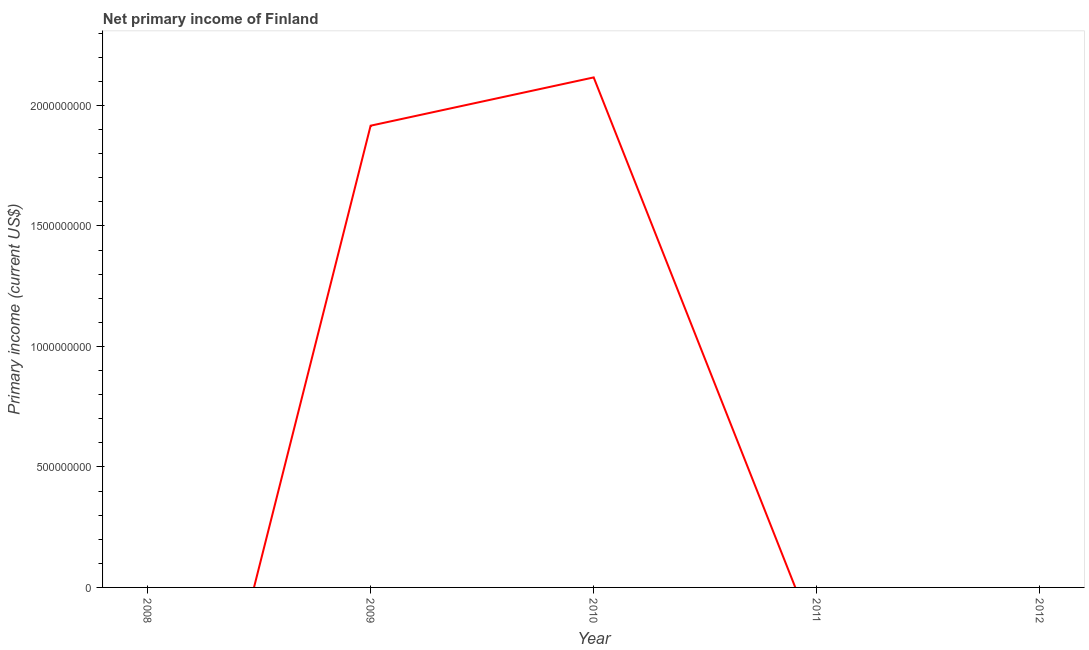What is the amount of primary income in 2009?
Your answer should be compact. 1.92e+09. Across all years, what is the maximum amount of primary income?
Offer a very short reply. 2.12e+09. In which year was the amount of primary income maximum?
Ensure brevity in your answer.  2010. What is the sum of the amount of primary income?
Your answer should be very brief. 4.03e+09. What is the difference between the amount of primary income in 2009 and 2010?
Give a very brief answer. -2.00e+08. What is the average amount of primary income per year?
Give a very brief answer. 8.06e+08. In how many years, is the amount of primary income greater than 300000000 US$?
Offer a very short reply. 2. What is the ratio of the amount of primary income in 2009 to that in 2010?
Make the answer very short. 0.91. What is the difference between the highest and the lowest amount of primary income?
Make the answer very short. 2.12e+09. In how many years, is the amount of primary income greater than the average amount of primary income taken over all years?
Keep it short and to the point. 2. How many lines are there?
Offer a very short reply. 1. How many years are there in the graph?
Keep it short and to the point. 5. Does the graph contain any zero values?
Make the answer very short. Yes. Does the graph contain grids?
Ensure brevity in your answer.  No. What is the title of the graph?
Keep it short and to the point. Net primary income of Finland. What is the label or title of the Y-axis?
Your response must be concise. Primary income (current US$). What is the Primary income (current US$) of 2008?
Your answer should be compact. 0. What is the Primary income (current US$) in 2009?
Your answer should be very brief. 1.92e+09. What is the Primary income (current US$) of 2010?
Ensure brevity in your answer.  2.12e+09. What is the Primary income (current US$) in 2011?
Offer a very short reply. 0. What is the Primary income (current US$) in 2012?
Ensure brevity in your answer.  0. What is the difference between the Primary income (current US$) in 2009 and 2010?
Your answer should be compact. -2.00e+08. What is the ratio of the Primary income (current US$) in 2009 to that in 2010?
Your answer should be compact. 0.91. 